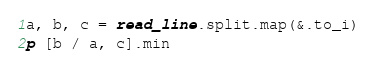<code> <loc_0><loc_0><loc_500><loc_500><_Crystal_>a, b, c = read_line.split.map(&.to_i)
p [b / a, c].min</code> 